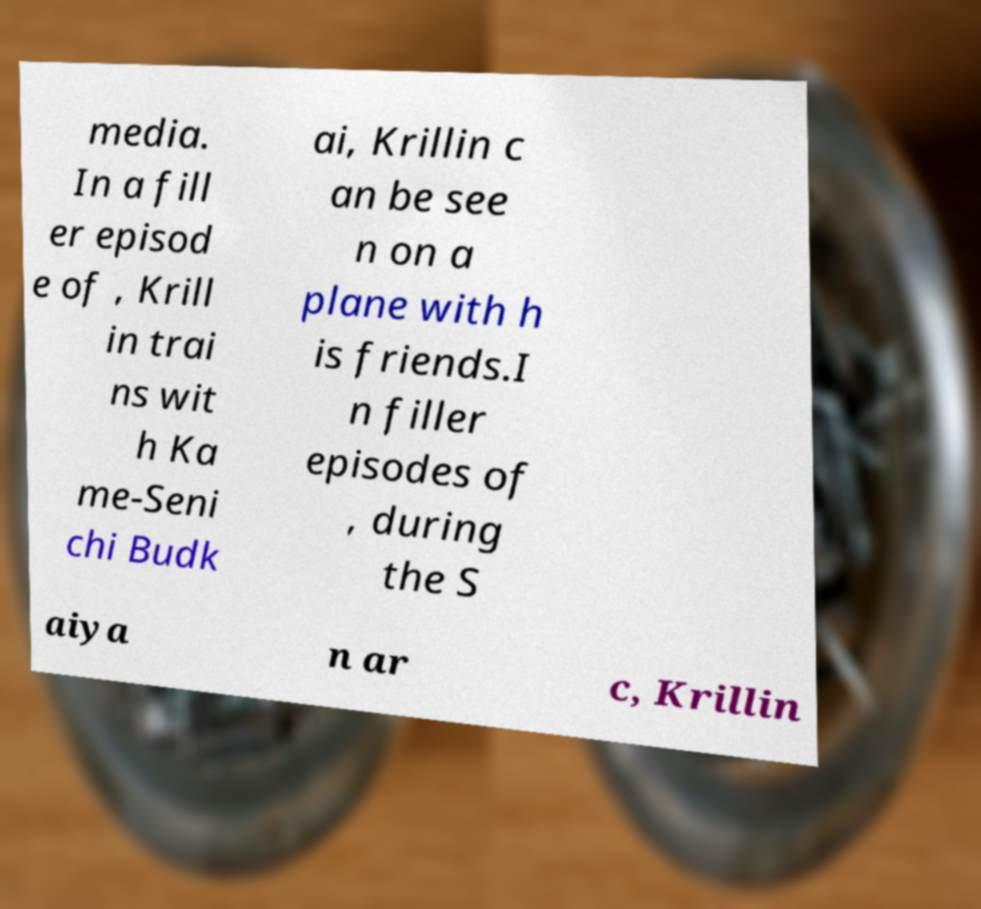Please identify and transcribe the text found in this image. media. In a fill er episod e of , Krill in trai ns wit h Ka me-Seni chi Budk ai, Krillin c an be see n on a plane with h is friends.I n filler episodes of , during the S aiya n ar c, Krillin 